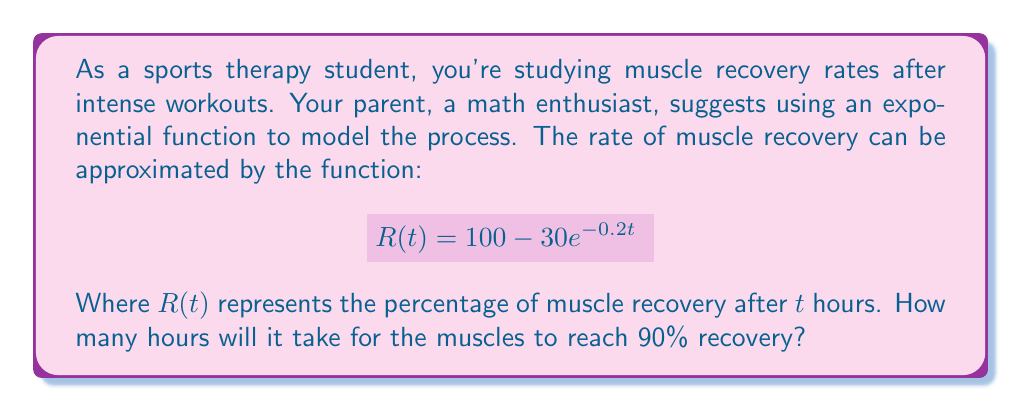Can you solve this math problem? To solve this problem, we need to follow these steps:

1) We want to find $t$ when $R(t) = 90$. So, we set up the equation:

   $$90 = 100 - 30e^{-0.2t}$$

2) Subtract 100 from both sides:

   $$-10 = -30e^{-0.2t}$$

3) Divide both sides by -30:

   $$\frac{1}{3} = e^{-0.2t}$$

4) Take the natural logarithm of both sides:

   $$\ln(\frac{1}{3}) = \ln(e^{-0.2t})$$

5) Simplify the right side using the properties of logarithms:

   $$\ln(\frac{1}{3}) = -0.2t$$

6) Divide both sides by -0.2:

   $$\frac{\ln(\frac{1}{3})}{-0.2} = t$$

7) Calculate the value (you can use a calculator for this):

   $$t \approx 5.5452$$

Therefore, it will take approximately 5.55 hours for the muscles to reach 90% recovery.
Answer: $t \approx 5.55$ hours 